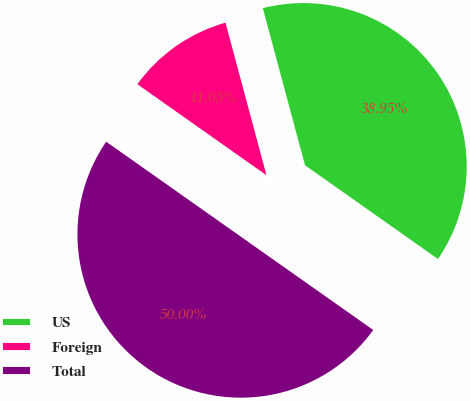Convert chart. <chart><loc_0><loc_0><loc_500><loc_500><pie_chart><fcel>US<fcel>Foreign<fcel>Total<nl><fcel>38.95%<fcel>11.05%<fcel>50.0%<nl></chart> 